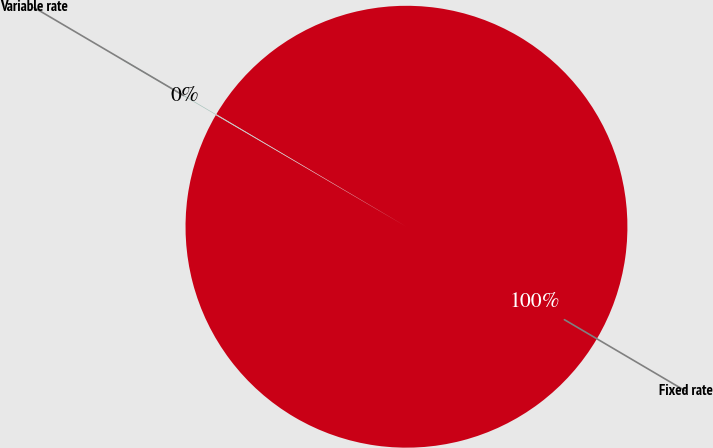Convert chart to OTSL. <chart><loc_0><loc_0><loc_500><loc_500><pie_chart><fcel>Fixed rate<fcel>Variable rate<nl><fcel>99.92%<fcel>0.08%<nl></chart> 